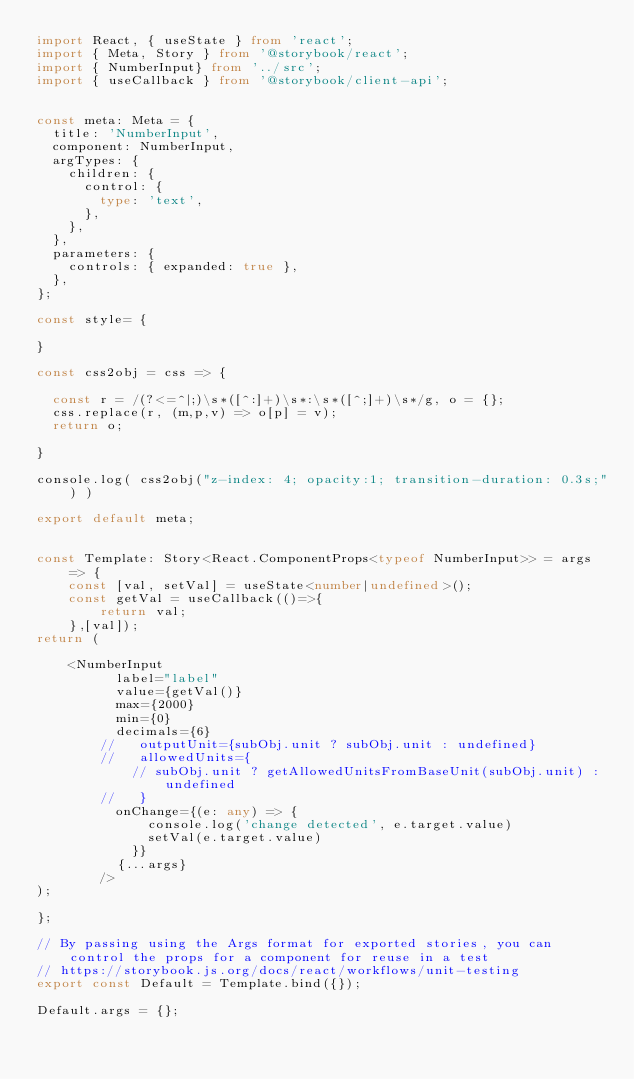<code> <loc_0><loc_0><loc_500><loc_500><_TypeScript_>import React, { useState } from 'react';
import { Meta, Story } from '@storybook/react';
import { NumberInput} from '../src';
import { useCallback } from '@storybook/client-api';


const meta: Meta = {
  title: 'NumberInput',
  component: NumberInput,
  argTypes: {
    children: {
      control: {
        type: 'text',
      },
    },
  },
  parameters: {
    controls: { expanded: true },
  },
};

const style= {

}

const css2obj = css => {
	
  const r = /(?<=^|;)\s*([^:]+)\s*:\s*([^;]+)\s*/g, o = {};
  css.replace(r, (m,p,v) => o[p] = v);
  return o;
	
}

console.log( css2obj("z-index: 4; opacity:1; transition-duration: 0.3s;") )

export default meta;


const Template: Story<React.ComponentProps<typeof NumberInput>> = args => {
    const [val, setVal] = useState<number|undefined>();
    const getVal = useCallback(()=>{
        return val;
    },[val]);
return (

    <NumberInput
          label="label"
          value={getVal()}
          max={2000}
          min={0}
          decimals={6}
        //   outputUnit={subObj.unit ? subObj.unit : undefined}
        //   allowedUnits={
            // subObj.unit ? getAllowedUnitsFromBaseUnit(subObj.unit) : undefined
        //   }
          onChange={(e: any) => {
              console.log('change detected', e.target.value)
              setVal(e.target.value)
            }}
          {...args}
        />
);

};

// By passing using the Args format for exported stories, you can control the props for a component for reuse in a test
// https://storybook.js.org/docs/react/workflows/unit-testing
export const Default = Template.bind({});

Default.args = {};
</code> 